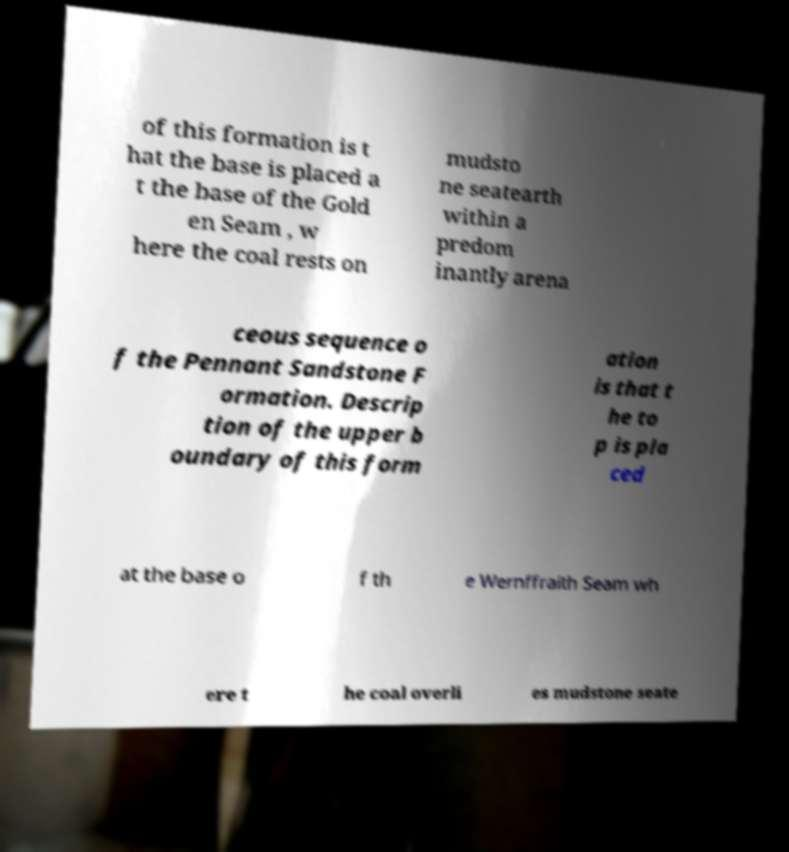Can you accurately transcribe the text from the provided image for me? of this formation is t hat the base is placed a t the base of the Gold en Seam , w here the coal rests on mudsto ne seatearth within a predom inantly arena ceous sequence o f the Pennant Sandstone F ormation. Descrip tion of the upper b oundary of this form ation is that t he to p is pla ced at the base o f th e Wernffraith Seam wh ere t he coal overli es mudstone seate 